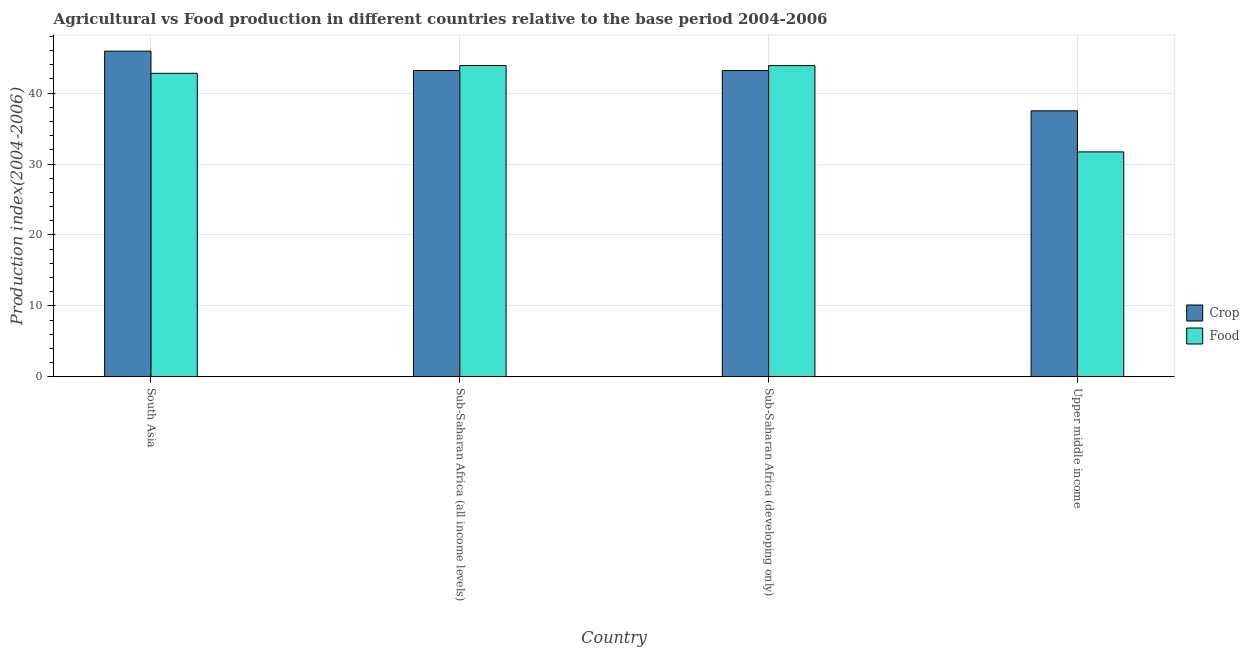What is the label of the 2nd group of bars from the left?
Provide a short and direct response. Sub-Saharan Africa (all income levels). In how many cases, is the number of bars for a given country not equal to the number of legend labels?
Provide a succinct answer. 0. What is the crop production index in Sub-Saharan Africa (developing only)?
Keep it short and to the point. 43.17. Across all countries, what is the maximum crop production index?
Your answer should be compact. 45.9. Across all countries, what is the minimum crop production index?
Give a very brief answer. 37.49. In which country was the crop production index maximum?
Make the answer very short. South Asia. In which country was the crop production index minimum?
Offer a terse response. Upper middle income. What is the total crop production index in the graph?
Your answer should be very brief. 169.74. What is the difference between the food production index in Sub-Saharan Africa (all income levels) and that in Sub-Saharan Africa (developing only)?
Offer a very short reply. 0. What is the difference between the crop production index in Sub-Saharan Africa (all income levels) and the food production index in Sub-Saharan Africa (developing only)?
Keep it short and to the point. -0.7. What is the average food production index per country?
Provide a succinct answer. 40.56. What is the difference between the food production index and crop production index in South Asia?
Your answer should be compact. -3.12. In how many countries, is the food production index greater than 34 ?
Your answer should be compact. 3. What is the ratio of the crop production index in Sub-Saharan Africa (all income levels) to that in Upper middle income?
Keep it short and to the point. 1.15. What is the difference between the highest and the second highest crop production index?
Offer a very short reply. 2.73. What is the difference between the highest and the lowest crop production index?
Your answer should be compact. 8.41. In how many countries, is the crop production index greater than the average crop production index taken over all countries?
Your answer should be compact. 3. What does the 2nd bar from the left in Upper middle income represents?
Give a very brief answer. Food. What does the 2nd bar from the right in Sub-Saharan Africa (developing only) represents?
Give a very brief answer. Crop. What is the difference between two consecutive major ticks on the Y-axis?
Provide a short and direct response. 10. Are the values on the major ticks of Y-axis written in scientific E-notation?
Keep it short and to the point. No. Does the graph contain grids?
Keep it short and to the point. Yes. Where does the legend appear in the graph?
Provide a short and direct response. Center right. How many legend labels are there?
Your answer should be very brief. 2. How are the legend labels stacked?
Your response must be concise. Vertical. What is the title of the graph?
Your response must be concise. Agricultural vs Food production in different countries relative to the base period 2004-2006. Does "Net National savings" appear as one of the legend labels in the graph?
Offer a very short reply. No. What is the label or title of the X-axis?
Keep it short and to the point. Country. What is the label or title of the Y-axis?
Your answer should be compact. Production index(2004-2006). What is the Production index(2004-2006) in Crop in South Asia?
Offer a terse response. 45.9. What is the Production index(2004-2006) in Food in South Asia?
Offer a very short reply. 42.78. What is the Production index(2004-2006) of Crop in Sub-Saharan Africa (all income levels)?
Your answer should be very brief. 43.18. What is the Production index(2004-2006) in Food in Sub-Saharan Africa (all income levels)?
Your response must be concise. 43.88. What is the Production index(2004-2006) in Crop in Sub-Saharan Africa (developing only)?
Give a very brief answer. 43.17. What is the Production index(2004-2006) of Food in Sub-Saharan Africa (developing only)?
Make the answer very short. 43.87. What is the Production index(2004-2006) in Crop in Upper middle income?
Your response must be concise. 37.49. What is the Production index(2004-2006) in Food in Upper middle income?
Provide a short and direct response. 31.71. Across all countries, what is the maximum Production index(2004-2006) of Crop?
Provide a succinct answer. 45.9. Across all countries, what is the maximum Production index(2004-2006) in Food?
Your answer should be very brief. 43.88. Across all countries, what is the minimum Production index(2004-2006) of Crop?
Make the answer very short. 37.49. Across all countries, what is the minimum Production index(2004-2006) of Food?
Make the answer very short. 31.71. What is the total Production index(2004-2006) of Crop in the graph?
Give a very brief answer. 169.74. What is the total Production index(2004-2006) in Food in the graph?
Provide a short and direct response. 162.24. What is the difference between the Production index(2004-2006) in Crop in South Asia and that in Sub-Saharan Africa (all income levels)?
Give a very brief answer. 2.73. What is the difference between the Production index(2004-2006) in Food in South Asia and that in Sub-Saharan Africa (all income levels)?
Your answer should be compact. -1.09. What is the difference between the Production index(2004-2006) of Crop in South Asia and that in Sub-Saharan Africa (developing only)?
Ensure brevity in your answer.  2.74. What is the difference between the Production index(2004-2006) of Food in South Asia and that in Sub-Saharan Africa (developing only)?
Keep it short and to the point. -1.09. What is the difference between the Production index(2004-2006) in Crop in South Asia and that in Upper middle income?
Provide a short and direct response. 8.41. What is the difference between the Production index(2004-2006) of Food in South Asia and that in Upper middle income?
Give a very brief answer. 11.08. What is the difference between the Production index(2004-2006) of Crop in Sub-Saharan Africa (all income levels) and that in Sub-Saharan Africa (developing only)?
Provide a succinct answer. 0.01. What is the difference between the Production index(2004-2006) in Food in Sub-Saharan Africa (all income levels) and that in Sub-Saharan Africa (developing only)?
Your answer should be compact. 0. What is the difference between the Production index(2004-2006) in Crop in Sub-Saharan Africa (all income levels) and that in Upper middle income?
Provide a succinct answer. 5.68. What is the difference between the Production index(2004-2006) in Food in Sub-Saharan Africa (all income levels) and that in Upper middle income?
Keep it short and to the point. 12.17. What is the difference between the Production index(2004-2006) of Crop in Sub-Saharan Africa (developing only) and that in Upper middle income?
Make the answer very short. 5.67. What is the difference between the Production index(2004-2006) in Food in Sub-Saharan Africa (developing only) and that in Upper middle income?
Your answer should be very brief. 12.16. What is the difference between the Production index(2004-2006) in Crop in South Asia and the Production index(2004-2006) in Food in Sub-Saharan Africa (all income levels)?
Offer a very short reply. 2.03. What is the difference between the Production index(2004-2006) of Crop in South Asia and the Production index(2004-2006) of Food in Sub-Saharan Africa (developing only)?
Offer a very short reply. 2.03. What is the difference between the Production index(2004-2006) of Crop in South Asia and the Production index(2004-2006) of Food in Upper middle income?
Offer a very short reply. 14.2. What is the difference between the Production index(2004-2006) in Crop in Sub-Saharan Africa (all income levels) and the Production index(2004-2006) in Food in Sub-Saharan Africa (developing only)?
Your answer should be very brief. -0.7. What is the difference between the Production index(2004-2006) of Crop in Sub-Saharan Africa (all income levels) and the Production index(2004-2006) of Food in Upper middle income?
Keep it short and to the point. 11.47. What is the difference between the Production index(2004-2006) in Crop in Sub-Saharan Africa (developing only) and the Production index(2004-2006) in Food in Upper middle income?
Your response must be concise. 11.46. What is the average Production index(2004-2006) of Crop per country?
Make the answer very short. 42.43. What is the average Production index(2004-2006) of Food per country?
Offer a very short reply. 40.56. What is the difference between the Production index(2004-2006) of Crop and Production index(2004-2006) of Food in South Asia?
Your answer should be compact. 3.12. What is the difference between the Production index(2004-2006) in Crop and Production index(2004-2006) in Food in Sub-Saharan Africa (all income levels)?
Make the answer very short. -0.7. What is the difference between the Production index(2004-2006) in Crop and Production index(2004-2006) in Food in Sub-Saharan Africa (developing only)?
Your answer should be very brief. -0.7. What is the difference between the Production index(2004-2006) in Crop and Production index(2004-2006) in Food in Upper middle income?
Make the answer very short. 5.79. What is the ratio of the Production index(2004-2006) of Crop in South Asia to that in Sub-Saharan Africa (all income levels)?
Ensure brevity in your answer.  1.06. What is the ratio of the Production index(2004-2006) in Food in South Asia to that in Sub-Saharan Africa (all income levels)?
Ensure brevity in your answer.  0.98. What is the ratio of the Production index(2004-2006) of Crop in South Asia to that in Sub-Saharan Africa (developing only)?
Keep it short and to the point. 1.06. What is the ratio of the Production index(2004-2006) of Food in South Asia to that in Sub-Saharan Africa (developing only)?
Ensure brevity in your answer.  0.98. What is the ratio of the Production index(2004-2006) of Crop in South Asia to that in Upper middle income?
Ensure brevity in your answer.  1.22. What is the ratio of the Production index(2004-2006) of Food in South Asia to that in Upper middle income?
Offer a terse response. 1.35. What is the ratio of the Production index(2004-2006) of Food in Sub-Saharan Africa (all income levels) to that in Sub-Saharan Africa (developing only)?
Give a very brief answer. 1. What is the ratio of the Production index(2004-2006) in Crop in Sub-Saharan Africa (all income levels) to that in Upper middle income?
Ensure brevity in your answer.  1.15. What is the ratio of the Production index(2004-2006) of Food in Sub-Saharan Africa (all income levels) to that in Upper middle income?
Your answer should be very brief. 1.38. What is the ratio of the Production index(2004-2006) in Crop in Sub-Saharan Africa (developing only) to that in Upper middle income?
Your answer should be compact. 1.15. What is the ratio of the Production index(2004-2006) in Food in Sub-Saharan Africa (developing only) to that in Upper middle income?
Make the answer very short. 1.38. What is the difference between the highest and the second highest Production index(2004-2006) of Crop?
Your answer should be very brief. 2.73. What is the difference between the highest and the second highest Production index(2004-2006) in Food?
Ensure brevity in your answer.  0. What is the difference between the highest and the lowest Production index(2004-2006) in Crop?
Your response must be concise. 8.41. What is the difference between the highest and the lowest Production index(2004-2006) in Food?
Your response must be concise. 12.17. 